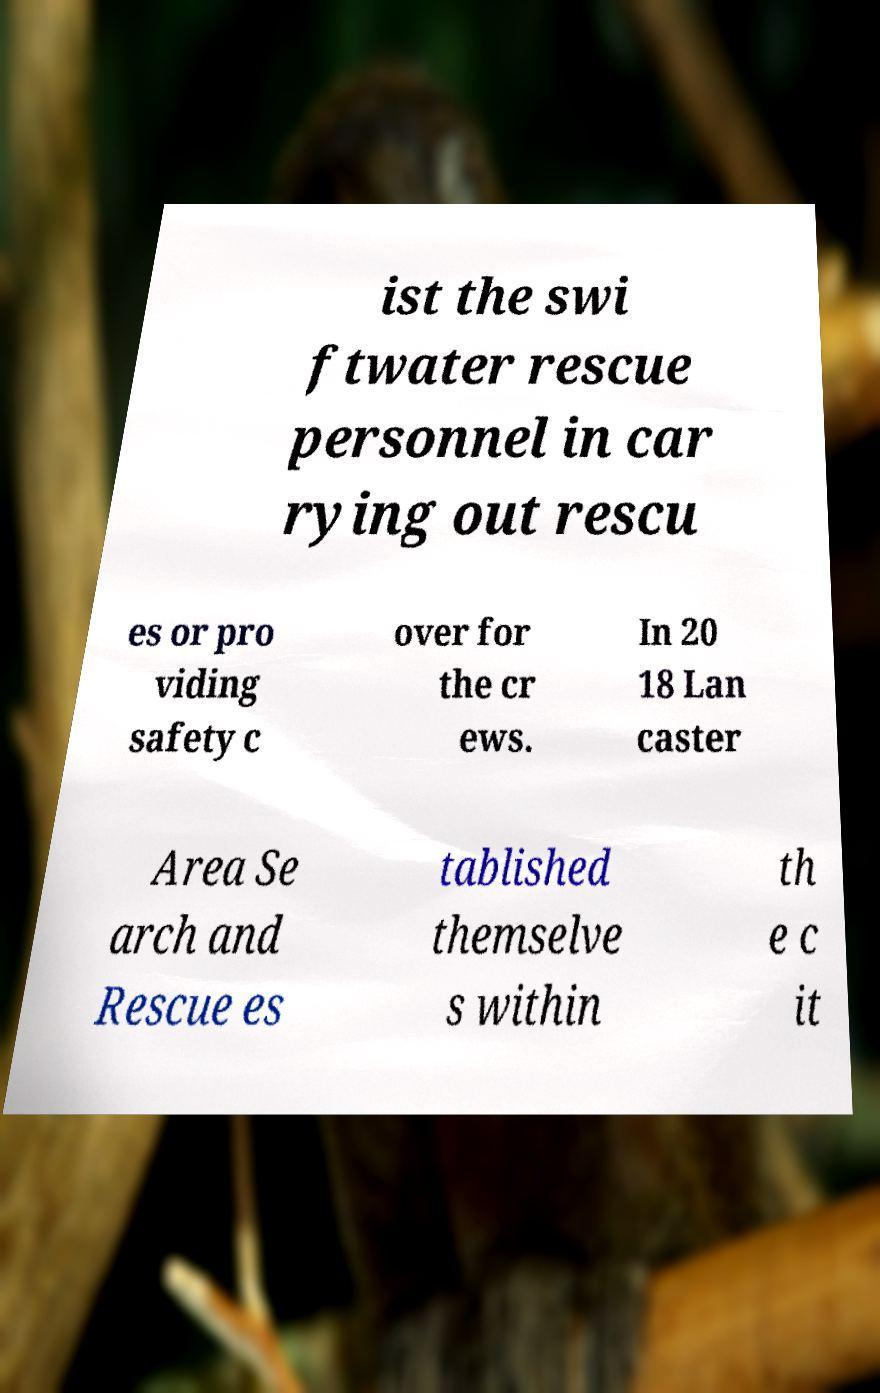For documentation purposes, I need the text within this image transcribed. Could you provide that? ist the swi ftwater rescue personnel in car rying out rescu es or pro viding safety c over for the cr ews. In 20 18 Lan caster Area Se arch and Rescue es tablished themselve s within th e c it 